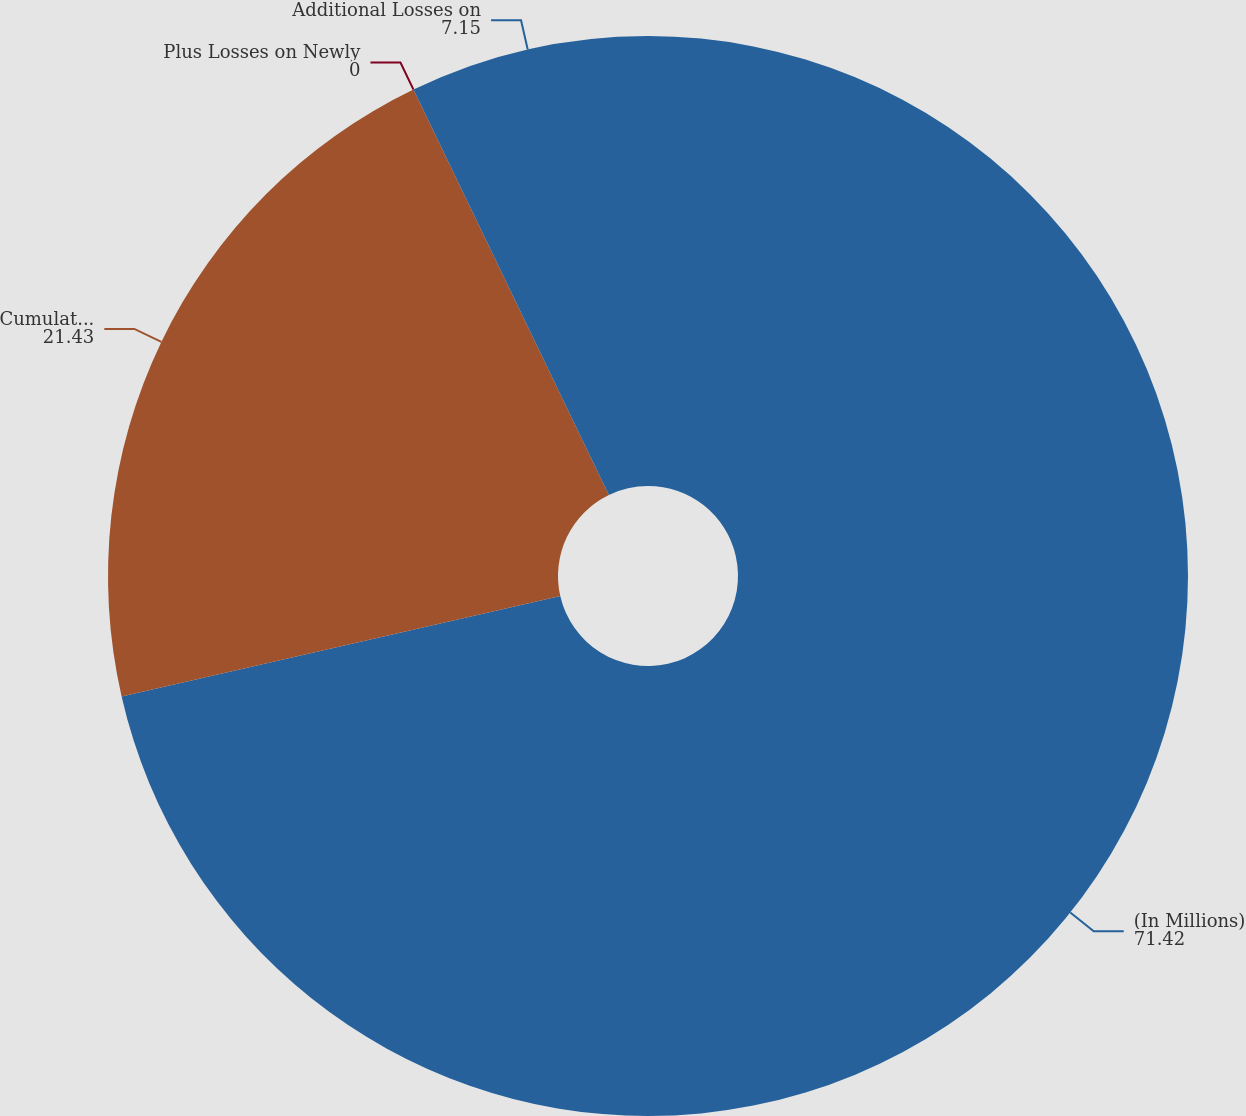<chart> <loc_0><loc_0><loc_500><loc_500><pie_chart><fcel>(In Millions)<fcel>Cumulative Credit-Related<fcel>Plus Losses on Newly<fcel>Additional Losses on<nl><fcel>71.42%<fcel>21.43%<fcel>0.0%<fcel>7.15%<nl></chart> 